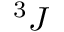Convert formula to latex. <formula><loc_0><loc_0><loc_500><loc_500>^ { 3 } J</formula> 